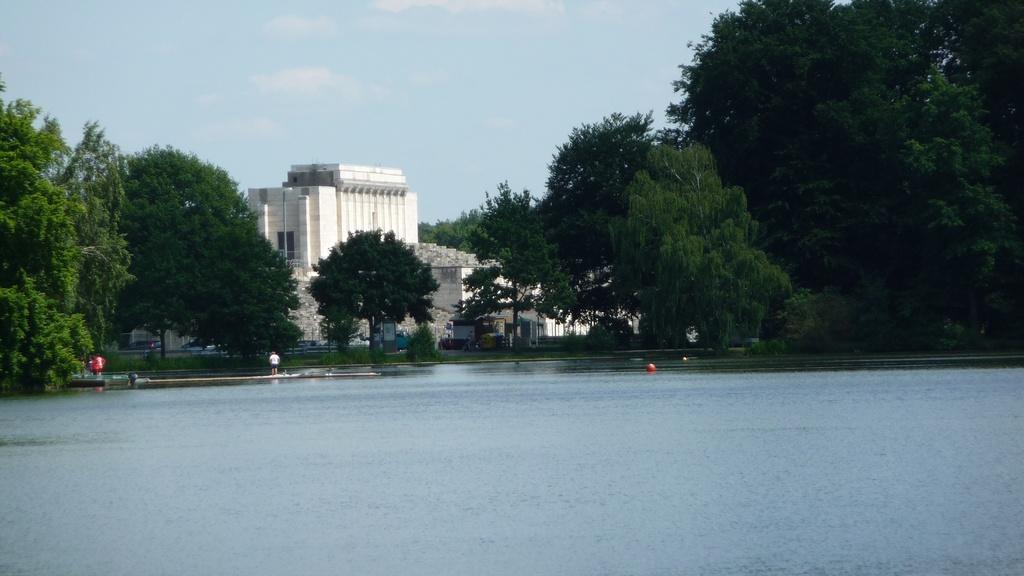Please provide a concise description of this image. At the bottom of the picture, we see water and this water might be in the lake. On the left side, we see the trees. Beside that, we see two people are standing. In the middle, we see a man in the white T-shirt is standing. On the right side, we see the trees. There are trees, buildings and poles in the background. At the top, we see the sky. 